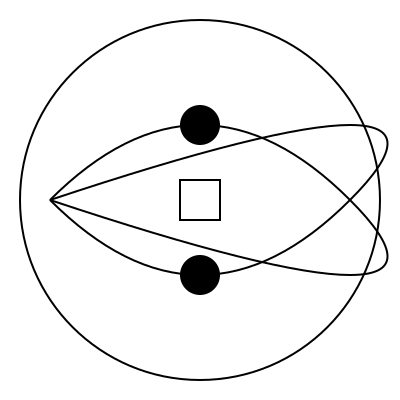In this abstract pattern inspired by Halsey's song "Colors," what shape would logically appear next if the pattern were to continue expanding outward? To determine the next shape in this pattern, we need to analyze the existing elements and their progression:

1. The outermost shape is a circle, encompassing all other elements.
2. Inside the circle, there are two interlocking wave-like patterns, reminiscent of the yin-yang symbol.
3. At the top and bottom of the inner space, there are two filled circles.
4. In the center, there's a square.

The pattern seems to progress from the outside inward, with each new element becoming simpler and more geometric:

Circle (complex) → Waves (curved) → Circles (simple) → Square (most basic)

Following this logic of simplification and considering basic geometric shapes, the next shape to appear if the pattern were to continue expanding outward would likely be a triangle. A triangle is the simplest polygon and would fit the progression from complex to simple shapes.

This interpretation also aligns with the symbolism in Halsey's "Colors," where different shapes and colors represent various emotions and experiences, gradually distilling into core elements.
Answer: Triangle 